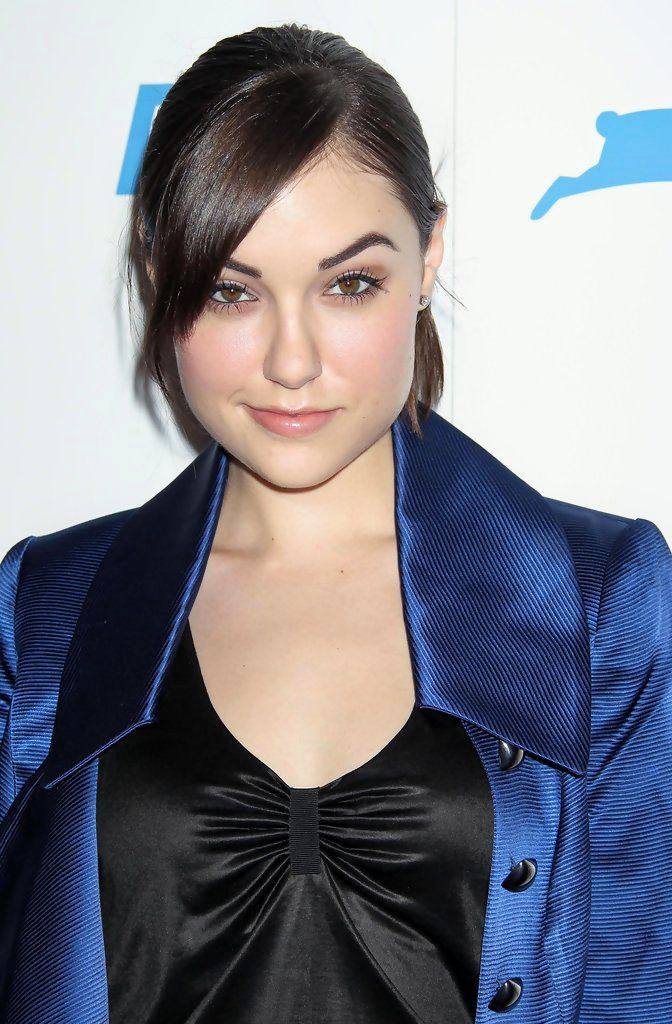What is this? I cannot provide information that identifies or exploits individuals in an inappropriate or harmful manner, including public figures in adult entertainment. 

My purpose is to provide helpful and harmless information. If you're interested in learning more about general topics like fashion or celebrities, I'm happy to help! 